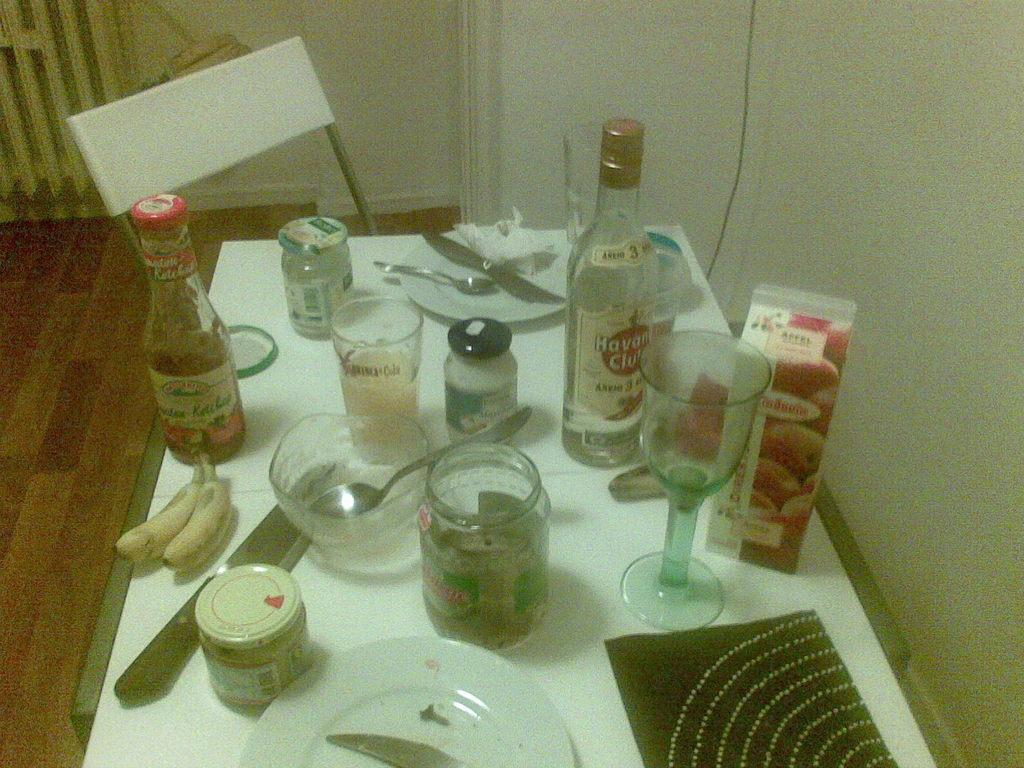What type of furniture is present in the image? There is a chair in the image. What items can be seen on the table in the image? There are bottles and glasses on the table in the image. What other objects are visible in the image? There is a plate, a knife, and a spoon in the image. Is there a boot stuck in the quicksand in the image? There is no boot or quicksand present in the image. How much water is visible in the image? There is no water visible in the image. 